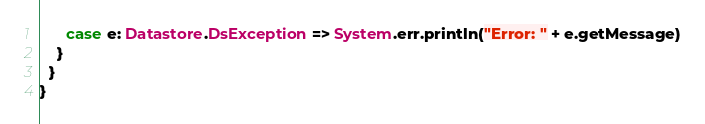<code> <loc_0><loc_0><loc_500><loc_500><_Scala_>      case e: Datastore.DsException => System.err.println("Error: " + e.getMessage)
    }
  }
}
</code> 